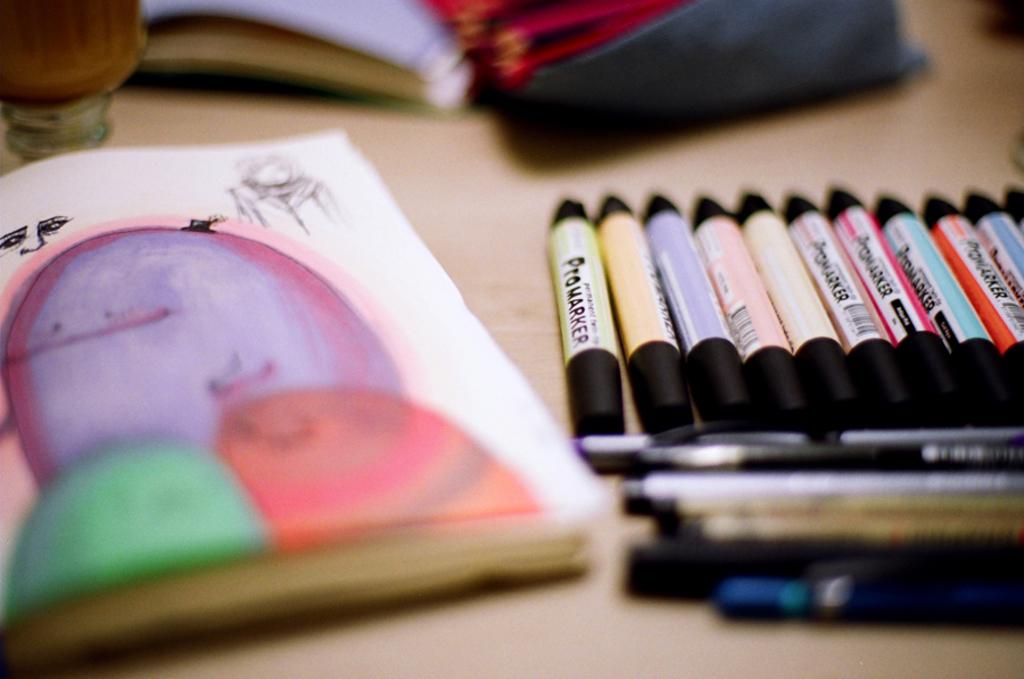What is the name of these markers?
Give a very brief answer. Promarker. 